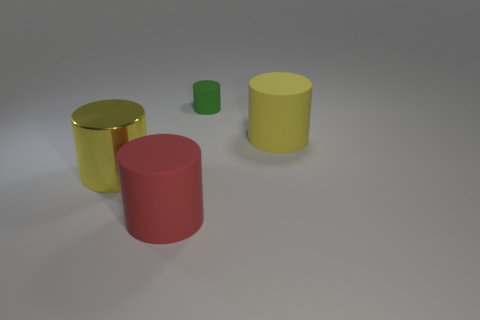Subtract all brown cylinders. Subtract all yellow spheres. How many cylinders are left? 4 Add 1 large red rubber things. How many objects exist? 5 Subtract all large cyan matte blocks. Subtract all large yellow shiny cylinders. How many objects are left? 3 Add 3 large cylinders. How many large cylinders are left? 6 Add 1 metallic things. How many metallic things exist? 2 Subtract 0 brown balls. How many objects are left? 4 